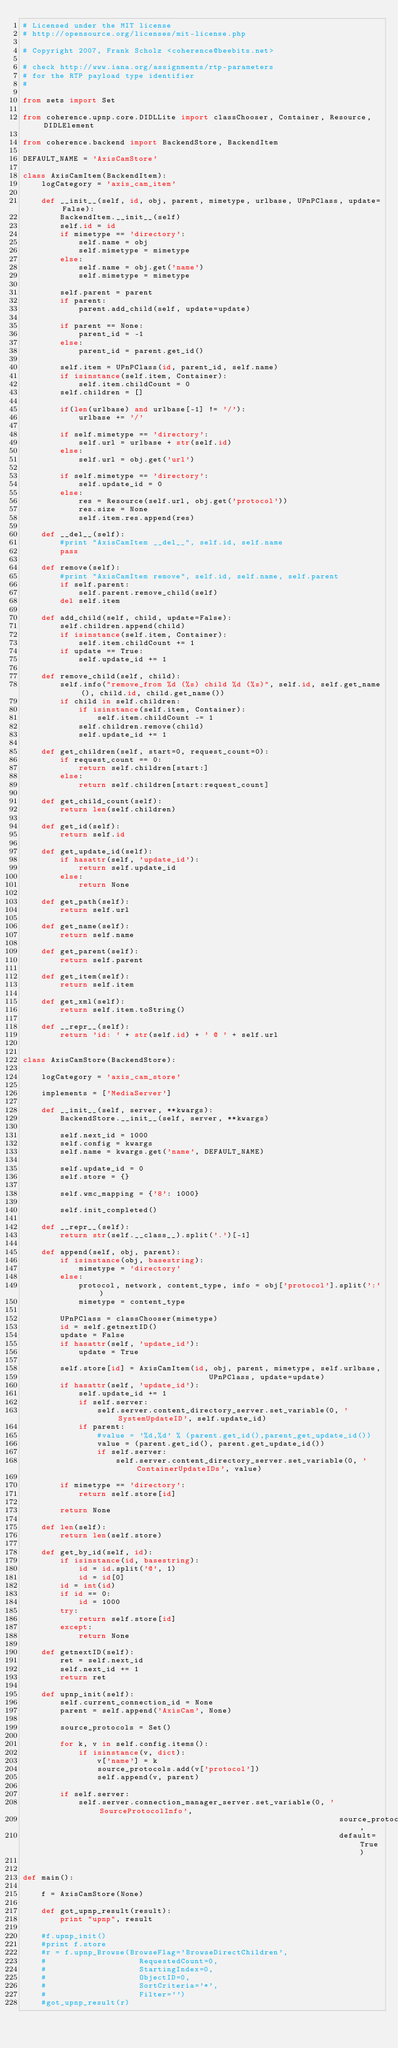<code> <loc_0><loc_0><loc_500><loc_500><_Python_># Licensed under the MIT license
# http://opensource.org/licenses/mit-license.php

# Copyright 2007, Frank Scholz <coherence@beebits.net>

# check http://www.iana.org/assignments/rtp-parameters
# for the RTP payload type identifier
#

from sets import Set

from coherence.upnp.core.DIDLLite import classChooser, Container, Resource, DIDLElement

from coherence.backend import BackendStore, BackendItem

DEFAULT_NAME = 'AxisCamStore'

class AxisCamItem(BackendItem):
    logCategory = 'axis_cam_item'

    def __init__(self, id, obj, parent, mimetype, urlbase, UPnPClass, update=False):
        BackendItem.__init__(self)
        self.id = id
        if mimetype == 'directory':
            self.name = obj
            self.mimetype = mimetype
        else:
            self.name = obj.get('name')
            self.mimetype = mimetype

        self.parent = parent
        if parent:
            parent.add_child(self, update=update)

        if parent == None:
            parent_id = -1
        else:
            parent_id = parent.get_id()

        self.item = UPnPClass(id, parent_id, self.name)
        if isinstance(self.item, Container):
            self.item.childCount = 0
        self.children = []

        if(len(urlbase) and urlbase[-1] != '/'):
            urlbase += '/'

        if self.mimetype == 'directory':
            self.url = urlbase + str(self.id)
        else:
            self.url = obj.get('url')

        if self.mimetype == 'directory':
            self.update_id = 0
        else:
            res = Resource(self.url, obj.get('protocol'))
            res.size = None
            self.item.res.append(res)

    def __del__(self):
        #print "AxisCamItem __del__", self.id, self.name
        pass

    def remove(self):
        #print "AxisCamItem remove", self.id, self.name, self.parent
        if self.parent:
            self.parent.remove_child(self)
        del self.item

    def add_child(self, child, update=False):
        self.children.append(child)
        if isinstance(self.item, Container):
            self.item.childCount += 1
        if update == True:
            self.update_id += 1

    def remove_child(self, child):
        self.info("remove_from %d (%s) child %d (%s)", self.id, self.get_name(), child.id, child.get_name())
        if child in self.children:
            if isinstance(self.item, Container):
                self.item.childCount -= 1
            self.children.remove(child)
            self.update_id += 1

    def get_children(self, start=0, request_count=0):
        if request_count == 0:
            return self.children[start:]
        else:
            return self.children[start:request_count]

    def get_child_count(self):
        return len(self.children)

    def get_id(self):
        return self.id

    def get_update_id(self):
        if hasattr(self, 'update_id'):
            return self.update_id
        else:
            return None

    def get_path(self):
        return self.url

    def get_name(self):
        return self.name

    def get_parent(self):
        return self.parent

    def get_item(self):
        return self.item

    def get_xml(self):
        return self.item.toString()

    def __repr__(self):
        return 'id: ' + str(self.id) + ' @ ' + self.url


class AxisCamStore(BackendStore):

    logCategory = 'axis_cam_store'

    implements = ['MediaServer']

    def __init__(self, server, **kwargs):
        BackendStore.__init__(self, server, **kwargs)

        self.next_id = 1000
        self.config = kwargs
        self.name = kwargs.get('name', DEFAULT_NAME)

        self.update_id = 0
        self.store = {}

        self.wmc_mapping = {'8': 1000}

        self.init_completed()

    def __repr__(self):
        return str(self.__class__).split('.')[-1]

    def append(self, obj, parent):
        if isinstance(obj, basestring):
            mimetype = 'directory'
        else:
            protocol, network, content_type, info = obj['protocol'].split(':')
            mimetype = content_type

        UPnPClass = classChooser(mimetype)
        id = self.getnextID()
        update = False
        if hasattr(self, 'update_id'):
            update = True

        self.store[id] = AxisCamItem(id, obj, parent, mimetype, self.urlbase,
                                        UPnPClass, update=update)
        if hasattr(self, 'update_id'):
            self.update_id += 1
            if self.server:
                self.server.content_directory_server.set_variable(0, 'SystemUpdateID', self.update_id)
            if parent:
                #value = '%d,%d' % (parent.get_id(),parent_get_update_id())
                value = (parent.get_id(), parent.get_update_id())
                if self.server:
                    self.server.content_directory_server.set_variable(0, 'ContainerUpdateIDs', value)

        if mimetype == 'directory':
            return self.store[id]

        return None

    def len(self):
        return len(self.store)

    def get_by_id(self, id):
        if isinstance(id, basestring):
            id = id.split('@', 1)
            id = id[0]
        id = int(id)
        if id == 0:
            id = 1000
        try:
            return self.store[id]
        except:
            return None

    def getnextID(self):
        ret = self.next_id
        self.next_id += 1
        return ret

    def upnp_init(self):
        self.current_connection_id = None
        parent = self.append('AxisCam', None)

        source_protocols = Set()

        for k, v in self.config.items():
            if isinstance(v, dict):
                v['name'] = k
                source_protocols.add(v['protocol'])
                self.append(v, parent)

        if self.server:
            self.server.connection_manager_server.set_variable(0, 'SourceProtocolInfo',
                                                                    source_protocols,
                                                                    default=True)


def main():

    f = AxisCamStore(None)

    def got_upnp_result(result):
        print "upnp", result

    #f.upnp_init()
    #print f.store
    #r = f.upnp_Browse(BrowseFlag='BrowseDirectChildren',
    #                    RequestedCount=0,
    #                    StartingIndex=0,
    #                    ObjectID=0,
    #                    SortCriteria='*',
    #                    Filter='')
    #got_upnp_result(r)

</code> 